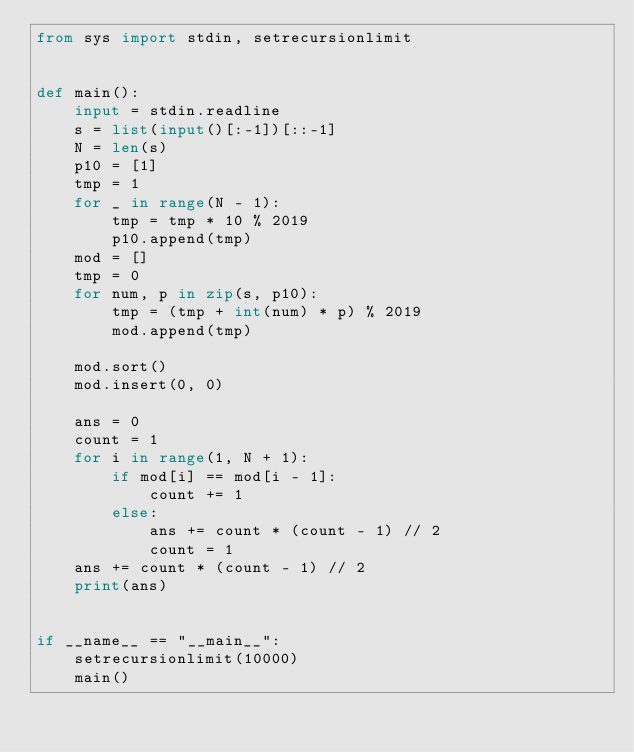<code> <loc_0><loc_0><loc_500><loc_500><_Python_>from sys import stdin, setrecursionlimit


def main():
    input = stdin.readline
    s = list(input()[:-1])[::-1]
    N = len(s)
    p10 = [1]
    tmp = 1
    for _ in range(N - 1):
        tmp = tmp * 10 % 2019
        p10.append(tmp)
    mod = []
    tmp = 0
    for num, p in zip(s, p10):
        tmp = (tmp + int(num) * p) % 2019
        mod.append(tmp)

    mod.sort()
    mod.insert(0, 0)

    ans = 0
    count = 1
    for i in range(1, N + 1):
        if mod[i] == mod[i - 1]:
            count += 1
        else:
            ans += count * (count - 1) // 2
            count = 1
    ans += count * (count - 1) // 2
    print(ans)


if __name__ == "__main__":
    setrecursionlimit(10000)
    main()
</code> 